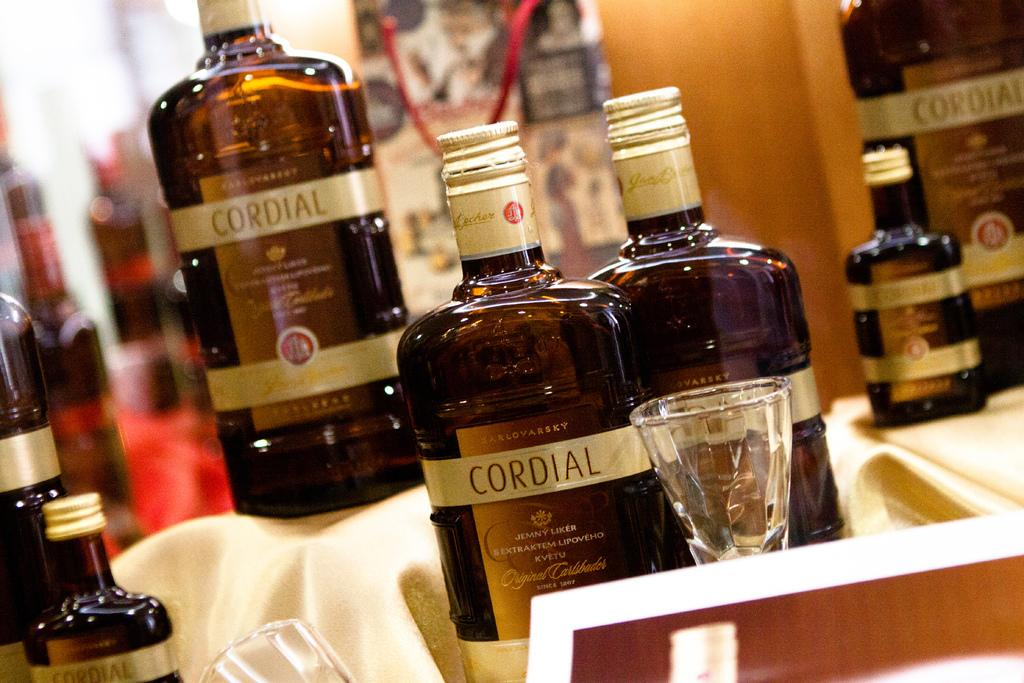<image>
Relay a brief, clear account of the picture shown. A couple of bottles labeled Cordial sit on display. 